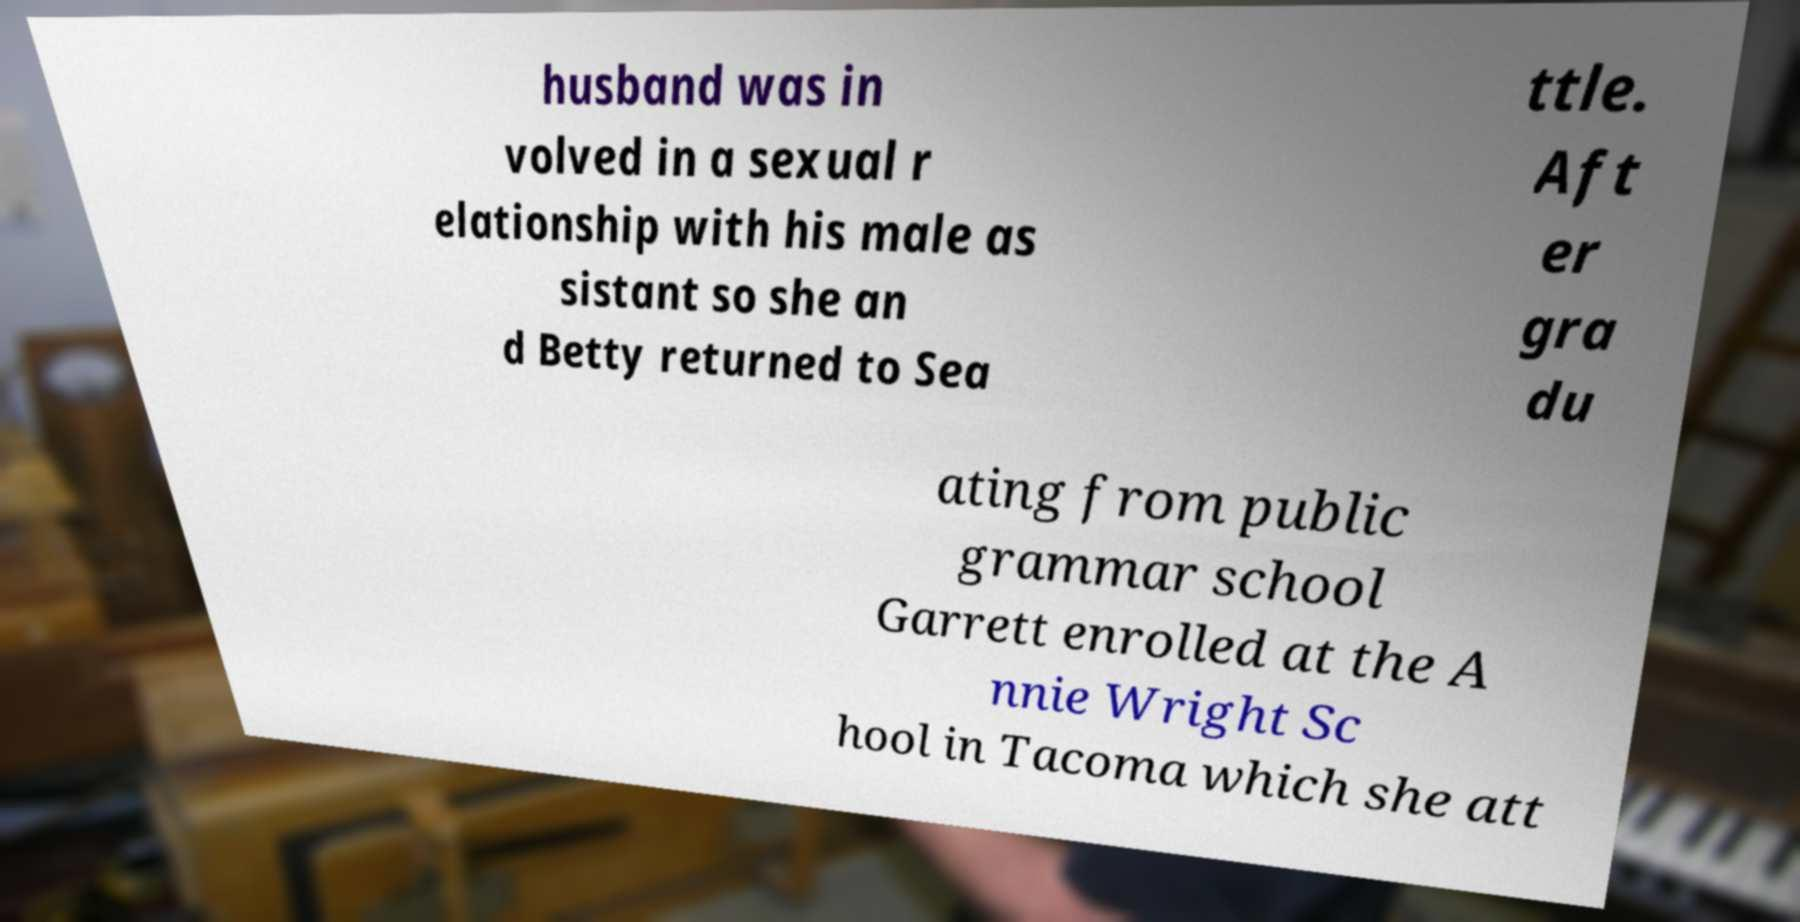There's text embedded in this image that I need extracted. Can you transcribe it verbatim? husband was in volved in a sexual r elationship with his male as sistant so she an d Betty returned to Sea ttle. Aft er gra du ating from public grammar school Garrett enrolled at the A nnie Wright Sc hool in Tacoma which she att 